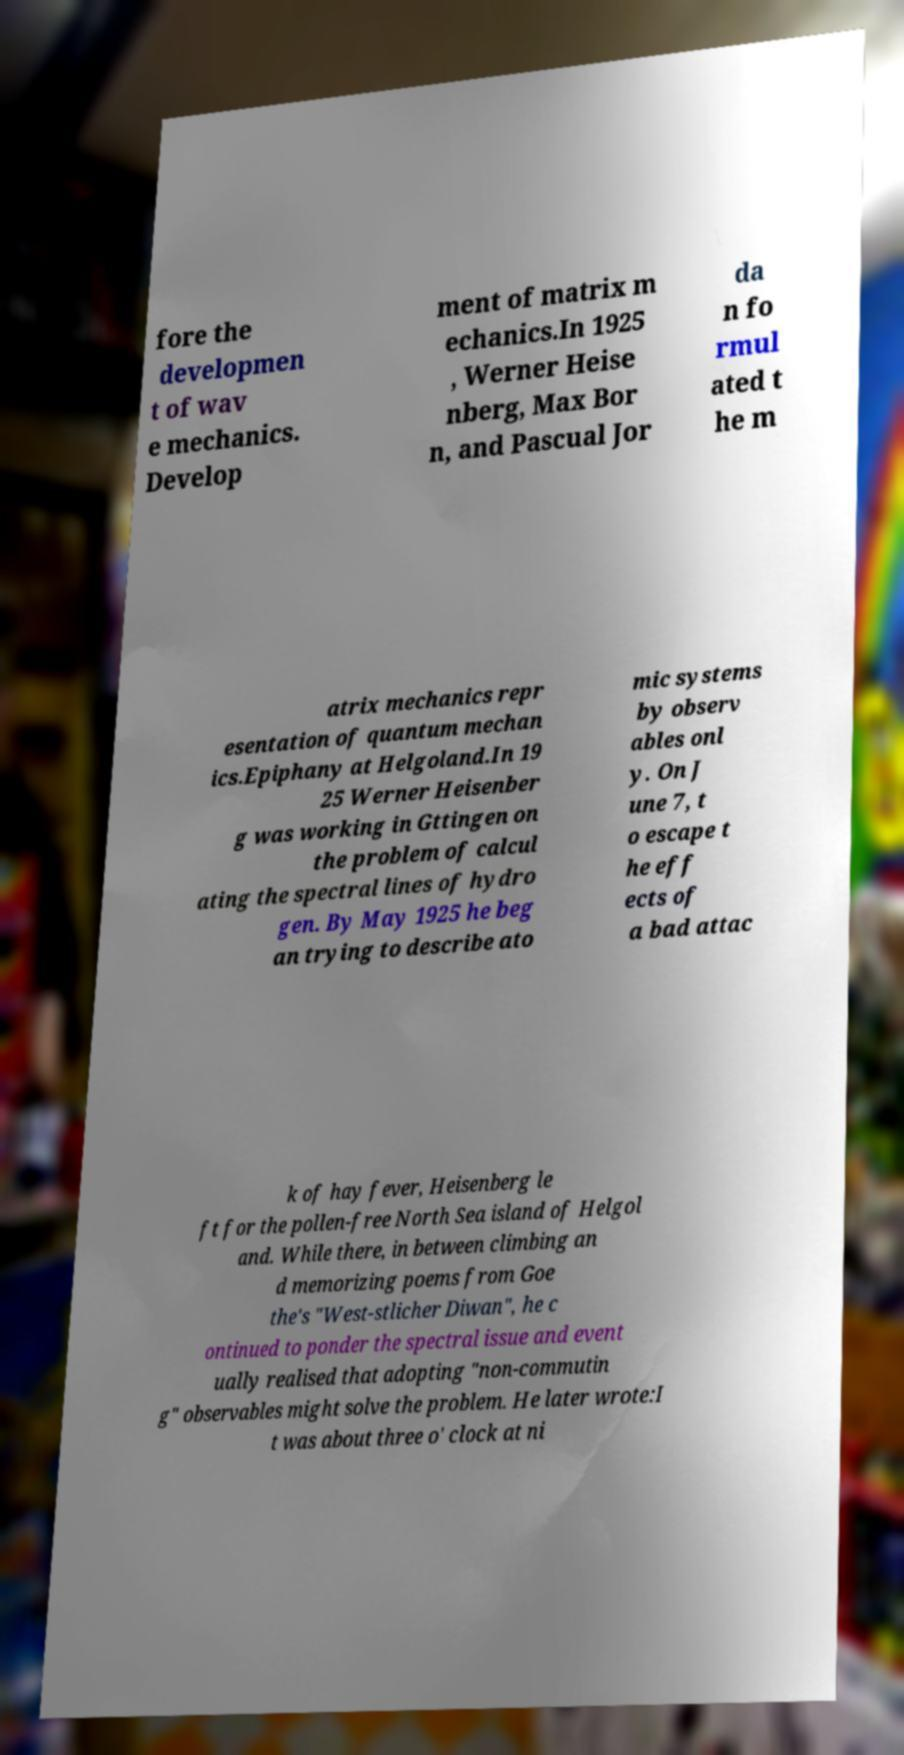I need the written content from this picture converted into text. Can you do that? fore the developmen t of wav e mechanics. Develop ment of matrix m echanics.In 1925 , Werner Heise nberg, Max Bor n, and Pascual Jor da n fo rmul ated t he m atrix mechanics repr esentation of quantum mechan ics.Epiphany at Helgoland.In 19 25 Werner Heisenber g was working in Gttingen on the problem of calcul ating the spectral lines of hydro gen. By May 1925 he beg an trying to describe ato mic systems by observ ables onl y. On J une 7, t o escape t he eff ects of a bad attac k of hay fever, Heisenberg le ft for the pollen-free North Sea island of Helgol and. While there, in between climbing an d memorizing poems from Goe the's "West-stlicher Diwan", he c ontinued to ponder the spectral issue and event ually realised that adopting "non-commutin g" observables might solve the problem. He later wrote:I t was about three o' clock at ni 